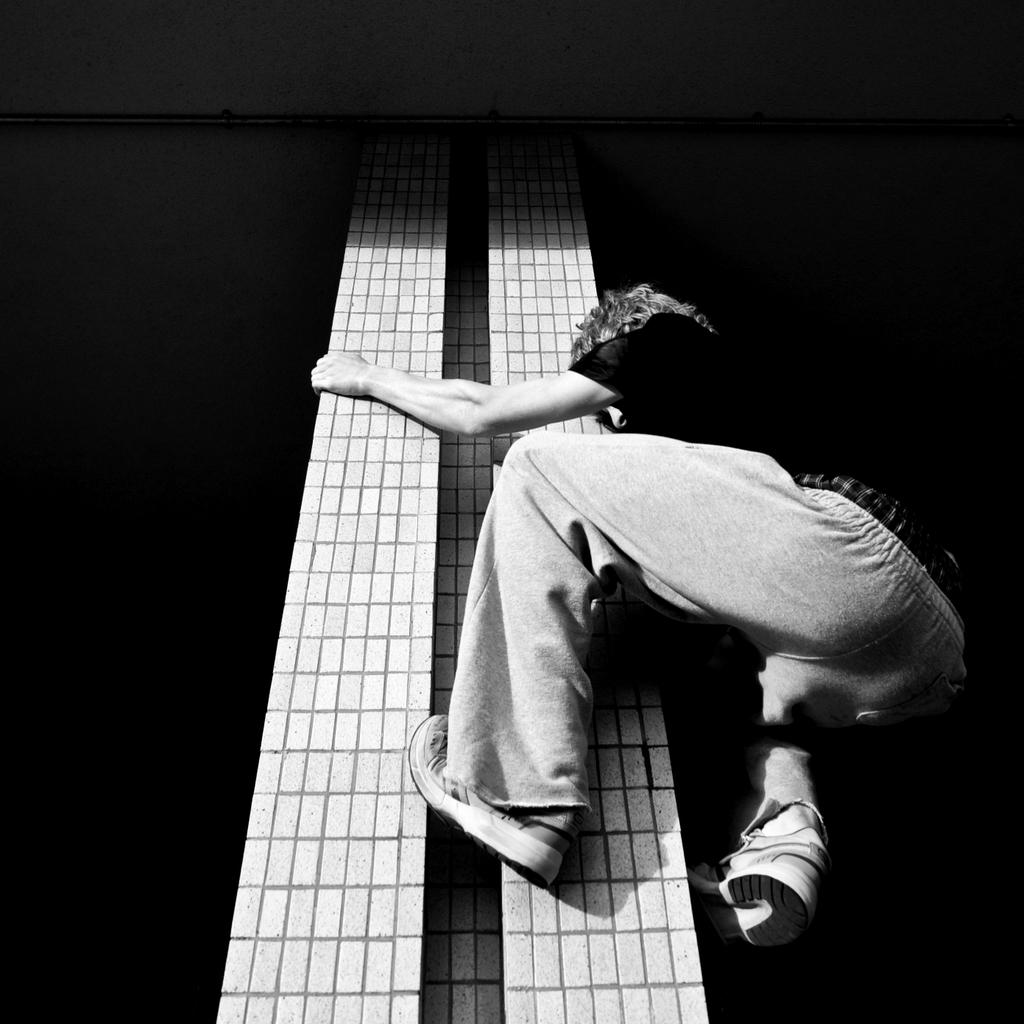What is the main subject of the image? There is a person in the image. What is the person wearing? The person is wearing a dress. What is the person doing in the image? The person is climbing a pillar. What is the color scheme of the image? The image is black and white. How many chickens are sleeping on the person's lip in the image? There are no chickens or lips present in the image, so this scenario cannot be observed. 